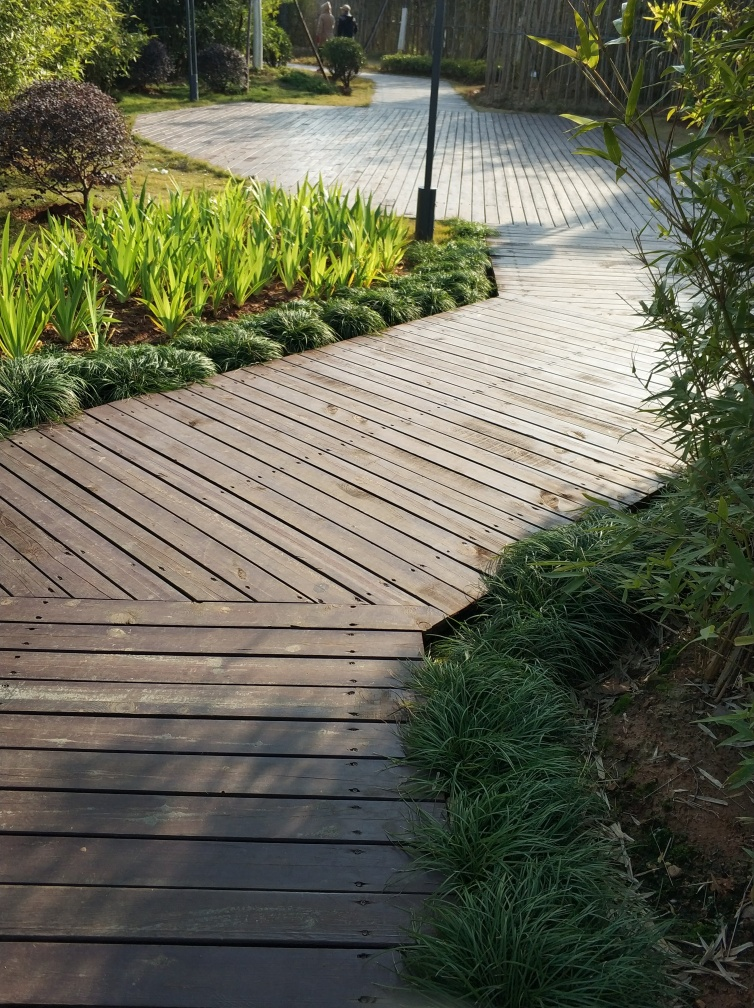What materials are used in the construction of this pathway? The pathway is constructed from wooden planks, likely designed for durability and aesthetics while blending with the natural surroundings. The use of wood suggests an emphasis on creating a space that coexists harmoniously with the environment. 